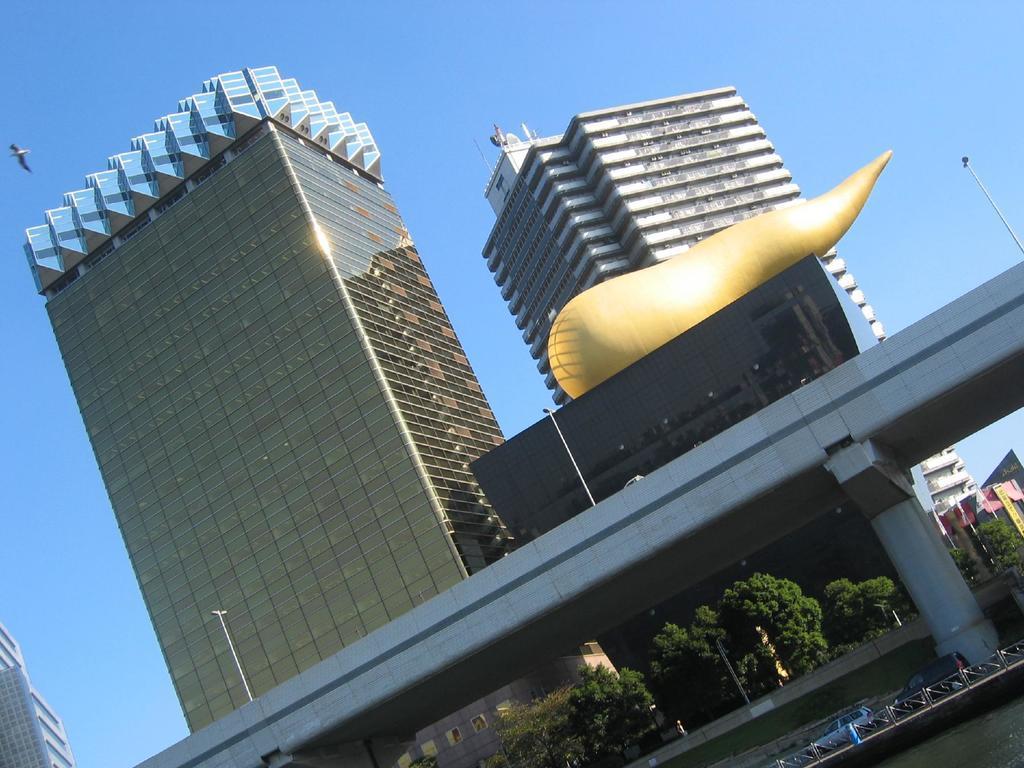Please provide a concise description of this image. In this image we can see buildings, bridge, poles, trees, vehicles, fence and in the background we can see the sky. 